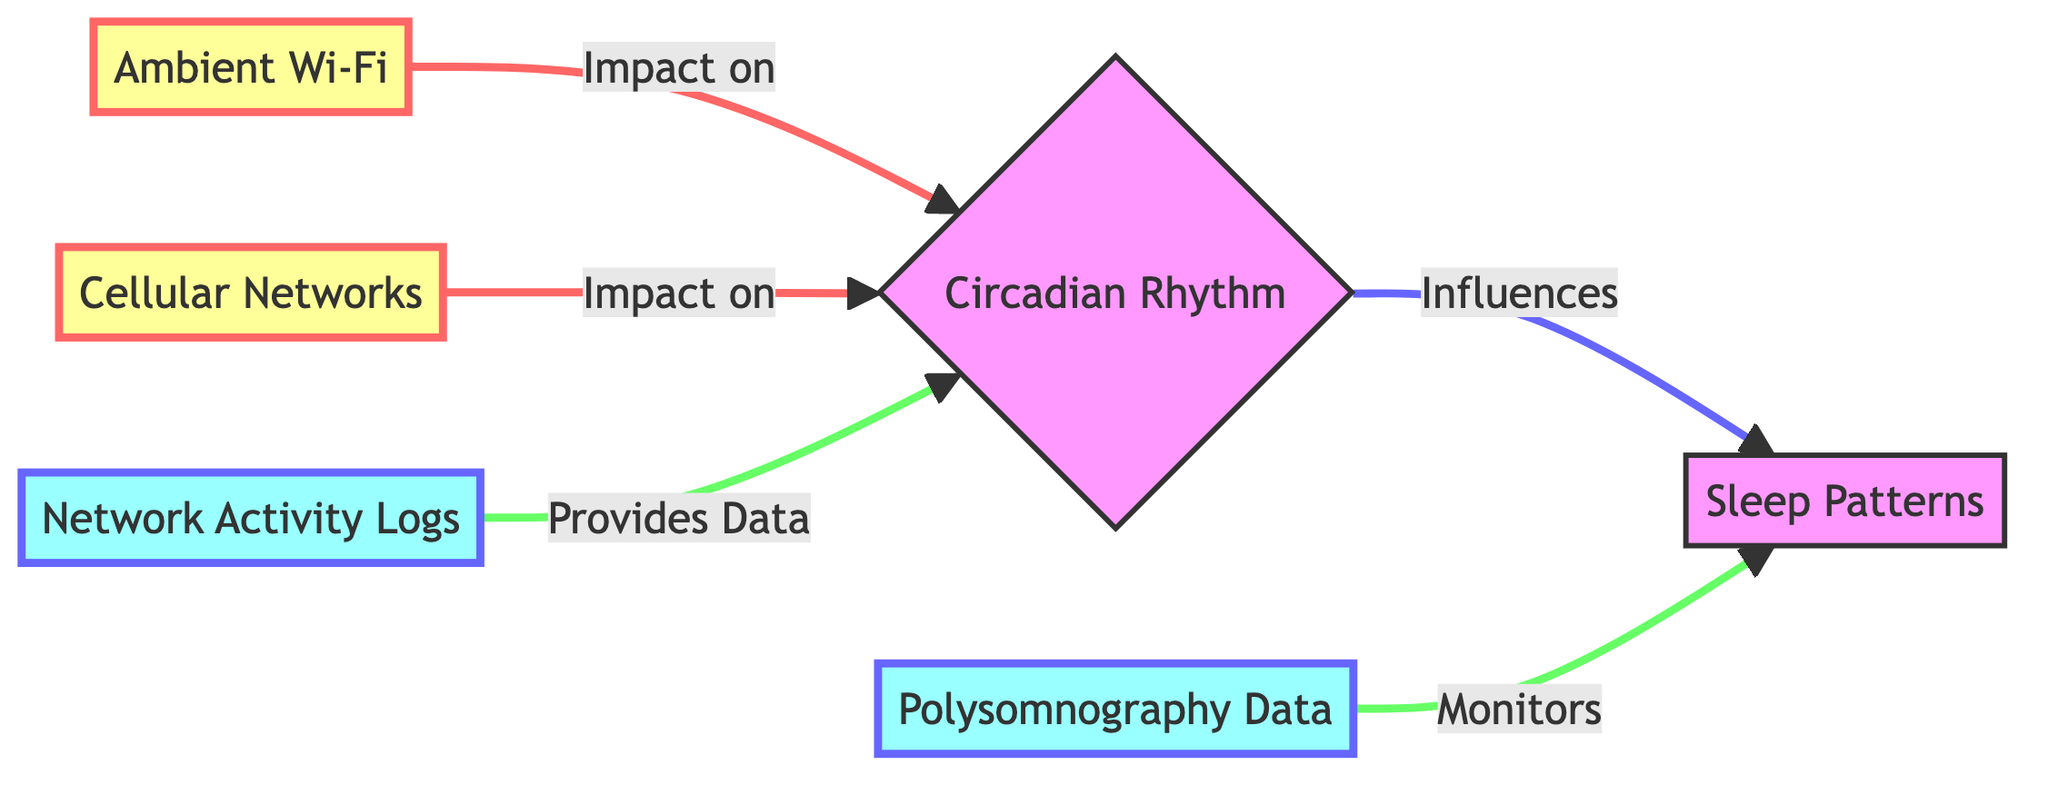What impacts circadian rhythm? The diagram shows that both Ambient Wi-Fi and Cellular Networks impact Circadian Rhythm, as indicated by the arrows leading to the Circadian Rhythm node.
Answer: Ambient Wi-Fi and Cellular Networks What monitors sleep patterns? The diagram indicates that Polysomnography Data monitors Sleep Patterns, as represented by the arrow leading from Polysomnography Data to Sleep Patterns.
Answer: Polysomnography Data How many total nodes are in the diagram? Counting all the unique nodes depicted in the diagram, there are six nodes: Ambient Wi-Fi, Cellular Networks, Circadian Rhythm, Sleep Patterns, Polysomnography Data, and Network Activity Logs.
Answer: Six What provides data for the circadian rhythm? The diagram specifies that Network Activity Logs provide data for Circadian Rhythm, as shown by the arrow connecting Network Activity Logs to Circadian Rhythm.
Answer: Network Activity Logs What influences sleep patterns? The Circadian Rhythm influences Sleep Patterns, as indicated by the directional arrow from Circadian Rhythm to Sleep Patterns in the diagram.
Answer: Circadian Rhythm Which two elements impact circadian rhythm? The diagram displays two elements that impact Circadian Rhythm: Ambient Wi-Fi and Cellular Networks, represented by arrows leading from these nodes to Circadian Rhythm.
Answer: Ambient Wi-Fi and Cellular Networks What type of diagram is this? The diagram, characterized by the flow of information related to the impact of networks on sleep, is classified as a Biomedical Diagram.
Answer: Biomedical Diagram Which node is a data node? The term 'data node' refers to nodes that handle specific data types. In this diagram, Polysomnography Data and Network Activity Logs are labeled as data nodes, confirmed by their distinctive color and role in the diagram.
Answer: Polysomnography Data and Network Activity Logs 